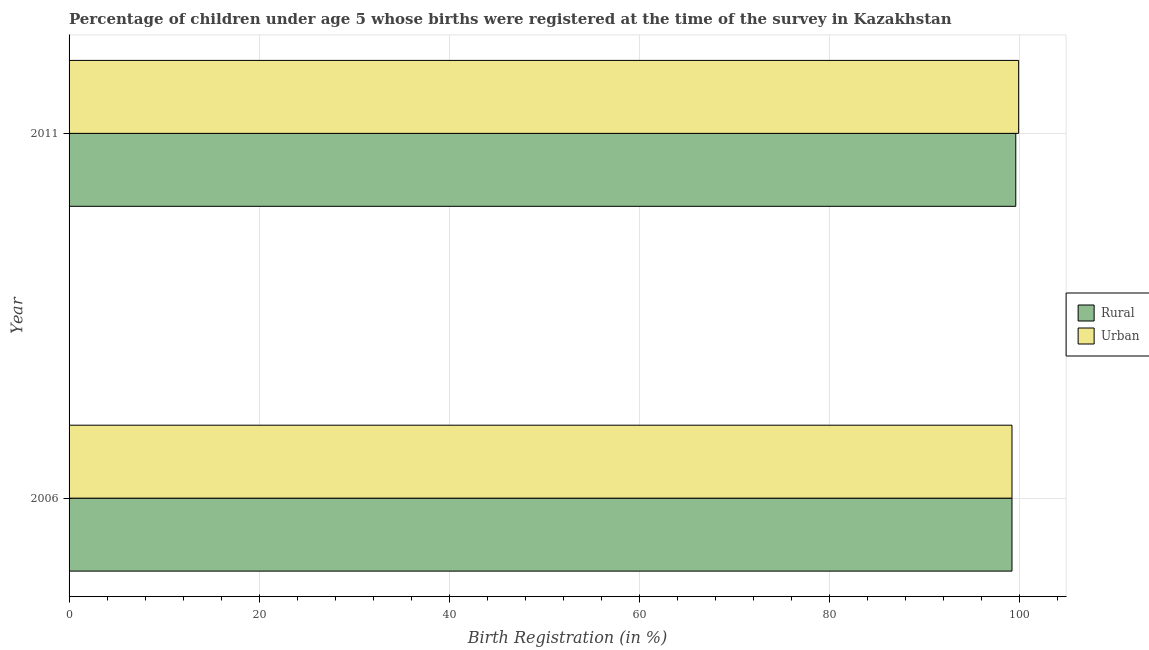How many different coloured bars are there?
Give a very brief answer. 2. Are the number of bars on each tick of the Y-axis equal?
Your answer should be very brief. Yes. How many bars are there on the 2nd tick from the top?
Keep it short and to the point. 2. What is the label of the 2nd group of bars from the top?
Make the answer very short. 2006. In how many cases, is the number of bars for a given year not equal to the number of legend labels?
Provide a short and direct response. 0. What is the urban birth registration in 2006?
Offer a terse response. 99.2. Across all years, what is the maximum rural birth registration?
Offer a very short reply. 99.6. Across all years, what is the minimum urban birth registration?
Provide a short and direct response. 99.2. In which year was the urban birth registration maximum?
Your answer should be compact. 2011. In which year was the rural birth registration minimum?
Offer a terse response. 2006. What is the total urban birth registration in the graph?
Offer a terse response. 199.1. What is the difference between the rural birth registration in 2006 and that in 2011?
Give a very brief answer. -0.4. What is the difference between the urban birth registration in 2006 and the rural birth registration in 2011?
Make the answer very short. -0.4. What is the average rural birth registration per year?
Provide a short and direct response. 99.4. Is the rural birth registration in 2006 less than that in 2011?
Offer a terse response. Yes. Is the difference between the urban birth registration in 2006 and 2011 greater than the difference between the rural birth registration in 2006 and 2011?
Provide a succinct answer. No. What does the 1st bar from the top in 2011 represents?
Provide a short and direct response. Urban. What does the 2nd bar from the bottom in 2006 represents?
Provide a succinct answer. Urban. How many bars are there?
Make the answer very short. 4. How many years are there in the graph?
Your answer should be compact. 2. What is the difference between two consecutive major ticks on the X-axis?
Offer a terse response. 20. Are the values on the major ticks of X-axis written in scientific E-notation?
Ensure brevity in your answer.  No. Does the graph contain any zero values?
Give a very brief answer. No. Where does the legend appear in the graph?
Provide a succinct answer. Center right. What is the title of the graph?
Your response must be concise. Percentage of children under age 5 whose births were registered at the time of the survey in Kazakhstan. Does "Foreign Liabilities" appear as one of the legend labels in the graph?
Give a very brief answer. No. What is the label or title of the X-axis?
Provide a short and direct response. Birth Registration (in %). What is the label or title of the Y-axis?
Offer a very short reply. Year. What is the Birth Registration (in %) of Rural in 2006?
Offer a very short reply. 99.2. What is the Birth Registration (in %) of Urban in 2006?
Your response must be concise. 99.2. What is the Birth Registration (in %) of Rural in 2011?
Provide a succinct answer. 99.6. What is the Birth Registration (in %) in Urban in 2011?
Provide a short and direct response. 99.9. Across all years, what is the maximum Birth Registration (in %) of Rural?
Keep it short and to the point. 99.6. Across all years, what is the maximum Birth Registration (in %) of Urban?
Keep it short and to the point. 99.9. Across all years, what is the minimum Birth Registration (in %) in Rural?
Give a very brief answer. 99.2. Across all years, what is the minimum Birth Registration (in %) in Urban?
Keep it short and to the point. 99.2. What is the total Birth Registration (in %) of Rural in the graph?
Provide a succinct answer. 198.8. What is the total Birth Registration (in %) of Urban in the graph?
Your response must be concise. 199.1. What is the difference between the Birth Registration (in %) in Rural in 2006 and that in 2011?
Offer a terse response. -0.4. What is the average Birth Registration (in %) of Rural per year?
Your answer should be compact. 99.4. What is the average Birth Registration (in %) of Urban per year?
Make the answer very short. 99.55. In the year 2006, what is the difference between the Birth Registration (in %) in Rural and Birth Registration (in %) in Urban?
Provide a short and direct response. 0. What is the ratio of the Birth Registration (in %) in Rural in 2006 to that in 2011?
Provide a succinct answer. 1. What is the ratio of the Birth Registration (in %) of Urban in 2006 to that in 2011?
Offer a very short reply. 0.99. 